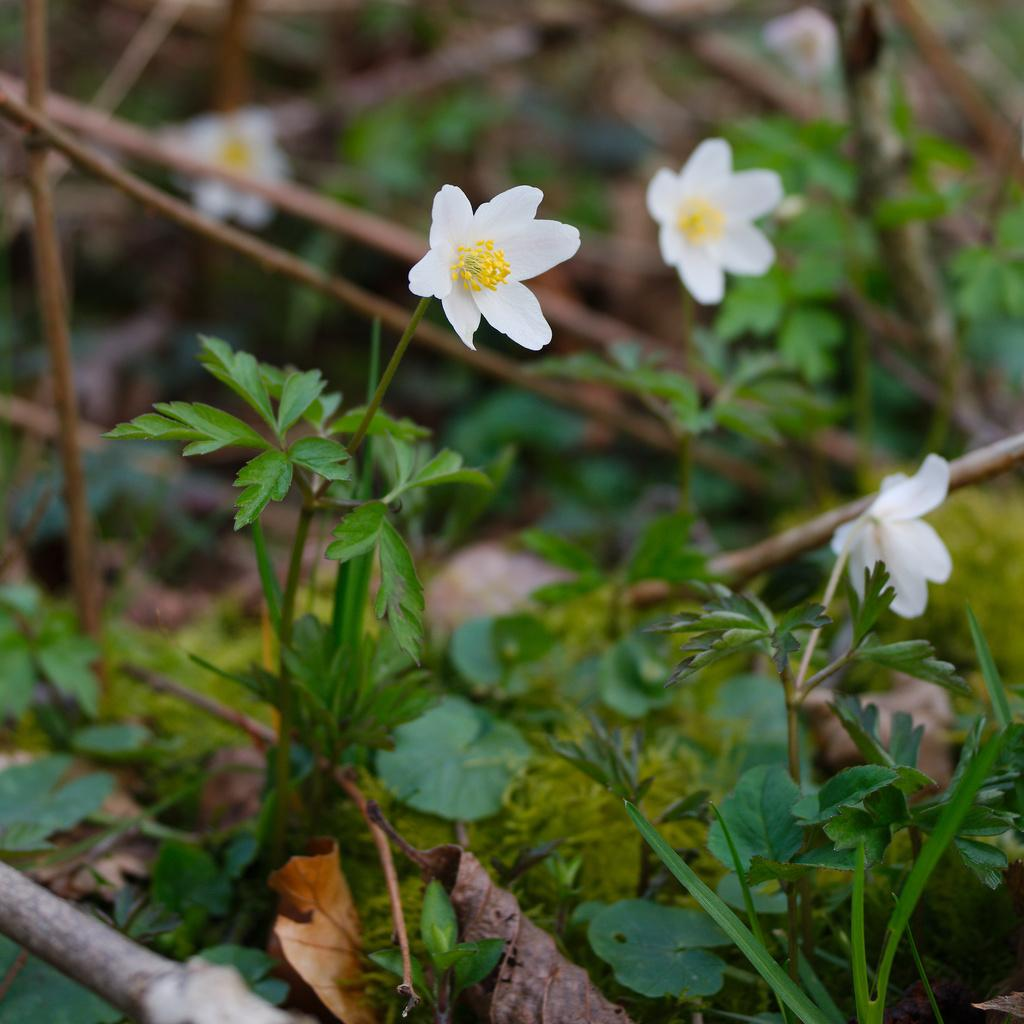What type of living organisms can be seen in the image? There are flowers and plants in the image. Can you describe the background of the image? The background of the image is blurred. How many feet are visible in the image? There are no feet present in the image. What type of crib can be seen in the image? There is no crib present in the image. 